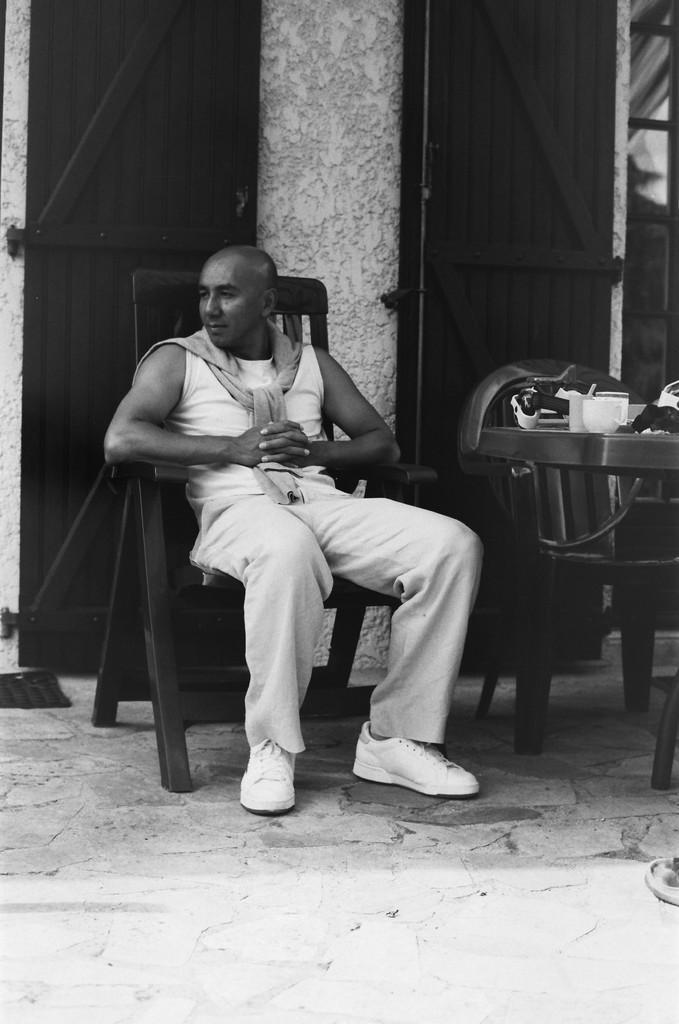What is the color scheme of the image? The image is black and white. What is the man in the image doing? The man is sitting on a chair. What is on the table in the image? There is a cup on the table, and there are objects on the table as well. How many chairs are visible in the image? There is one chair beside the man, making a total of two chairs in the image. What can be seen in the background of the image? There is a pillar, a glass, and a door in the background. What type of dinner is being served in the image? There is no dinner present in the image; it is a black and white image of a man sitting on a chair with a cup and objects on the table. 